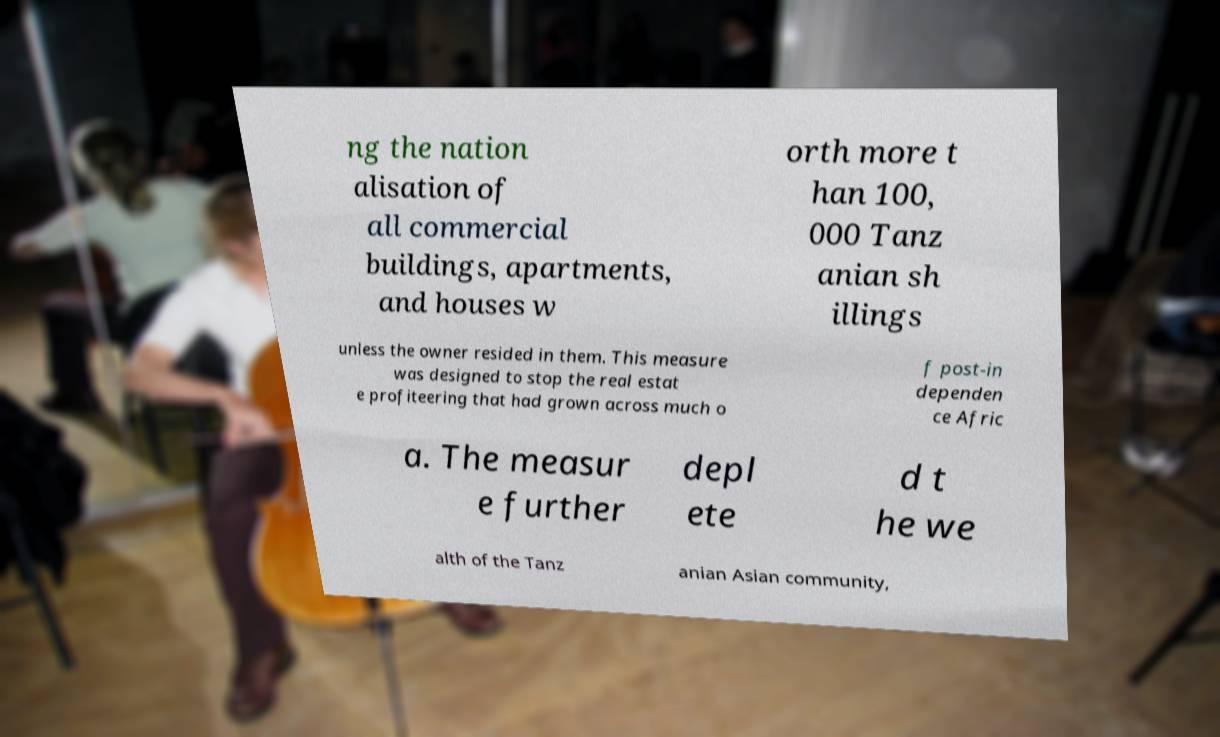Can you accurately transcribe the text from the provided image for me? ng the nation alisation of all commercial buildings, apartments, and houses w orth more t han 100, 000 Tanz anian sh illings unless the owner resided in them. This measure was designed to stop the real estat e profiteering that had grown across much o f post-in dependen ce Afric a. The measur e further depl ete d t he we alth of the Tanz anian Asian community, 